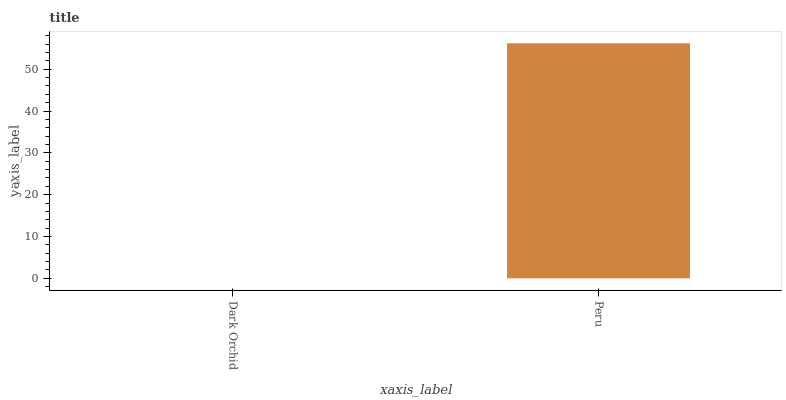Is Dark Orchid the minimum?
Answer yes or no. Yes. Is Peru the maximum?
Answer yes or no. Yes. Is Peru the minimum?
Answer yes or no. No. Is Peru greater than Dark Orchid?
Answer yes or no. Yes. Is Dark Orchid less than Peru?
Answer yes or no. Yes. Is Dark Orchid greater than Peru?
Answer yes or no. No. Is Peru less than Dark Orchid?
Answer yes or no. No. Is Peru the high median?
Answer yes or no. Yes. Is Dark Orchid the low median?
Answer yes or no. Yes. Is Dark Orchid the high median?
Answer yes or no. No. Is Peru the low median?
Answer yes or no. No. 